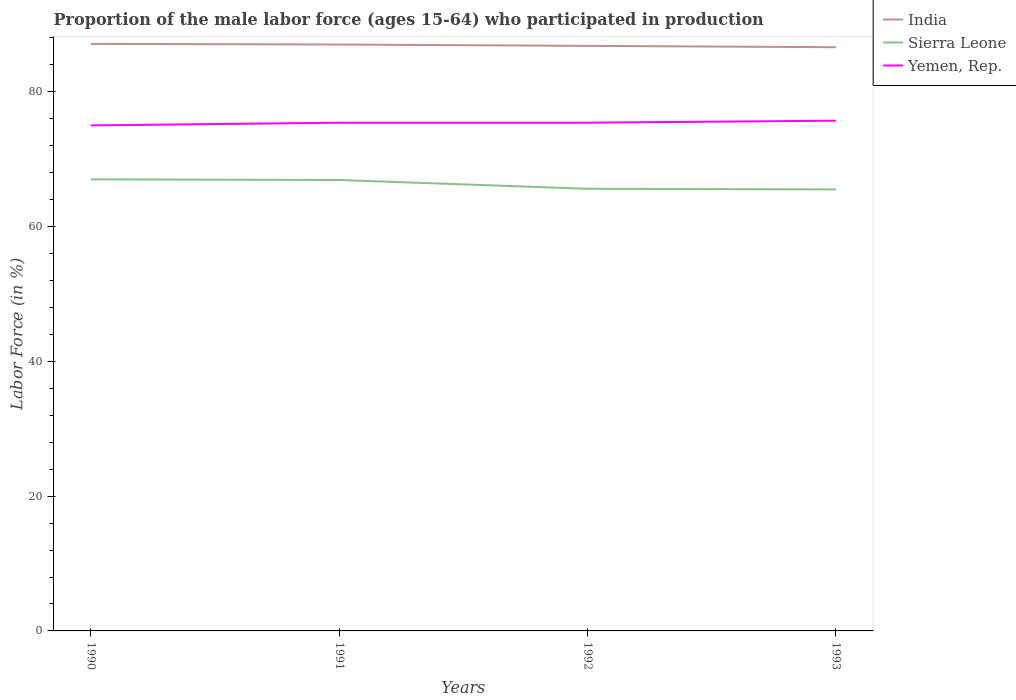How many different coloured lines are there?
Provide a short and direct response. 3. Is the number of lines equal to the number of legend labels?
Offer a terse response. Yes. Across all years, what is the maximum proportion of the male labor force who participated in production in Sierra Leone?
Offer a very short reply. 65.5. What is the total proportion of the male labor force who participated in production in Yemen, Rep. in the graph?
Make the answer very short. -0.7. How many years are there in the graph?
Give a very brief answer. 4. What is the difference between two consecutive major ticks on the Y-axis?
Ensure brevity in your answer.  20. How many legend labels are there?
Give a very brief answer. 3. How are the legend labels stacked?
Keep it short and to the point. Vertical. What is the title of the graph?
Your answer should be very brief. Proportion of the male labor force (ages 15-64) who participated in production. What is the label or title of the X-axis?
Provide a succinct answer. Years. What is the Labor Force (in %) in India in 1990?
Keep it short and to the point. 87.1. What is the Labor Force (in %) in Sierra Leone in 1991?
Provide a short and direct response. 66.9. What is the Labor Force (in %) in Yemen, Rep. in 1991?
Your answer should be compact. 75.4. What is the Labor Force (in %) of India in 1992?
Provide a short and direct response. 86.8. What is the Labor Force (in %) in Sierra Leone in 1992?
Your answer should be compact. 65.6. What is the Labor Force (in %) of Yemen, Rep. in 1992?
Your response must be concise. 75.4. What is the Labor Force (in %) in India in 1993?
Provide a succinct answer. 86.6. What is the Labor Force (in %) in Sierra Leone in 1993?
Make the answer very short. 65.5. What is the Labor Force (in %) of Yemen, Rep. in 1993?
Your response must be concise. 75.7. Across all years, what is the maximum Labor Force (in %) of India?
Your answer should be compact. 87.1. Across all years, what is the maximum Labor Force (in %) of Yemen, Rep.?
Give a very brief answer. 75.7. Across all years, what is the minimum Labor Force (in %) in India?
Offer a terse response. 86.6. Across all years, what is the minimum Labor Force (in %) of Sierra Leone?
Give a very brief answer. 65.5. What is the total Labor Force (in %) in India in the graph?
Your answer should be very brief. 347.5. What is the total Labor Force (in %) of Sierra Leone in the graph?
Offer a terse response. 265. What is the total Labor Force (in %) in Yemen, Rep. in the graph?
Give a very brief answer. 301.5. What is the difference between the Labor Force (in %) of India in 1990 and that in 1991?
Give a very brief answer. 0.1. What is the difference between the Labor Force (in %) of Sierra Leone in 1990 and that in 1991?
Your answer should be compact. 0.1. What is the difference between the Labor Force (in %) in India in 1990 and that in 1992?
Make the answer very short. 0.3. What is the difference between the Labor Force (in %) in Sierra Leone in 1990 and that in 1992?
Ensure brevity in your answer.  1.4. What is the difference between the Labor Force (in %) in Yemen, Rep. in 1990 and that in 1993?
Your answer should be compact. -0.7. What is the difference between the Labor Force (in %) of India in 1991 and that in 1993?
Give a very brief answer. 0.4. What is the difference between the Labor Force (in %) of Sierra Leone in 1991 and that in 1993?
Make the answer very short. 1.4. What is the difference between the Labor Force (in %) of Yemen, Rep. in 1991 and that in 1993?
Ensure brevity in your answer.  -0.3. What is the difference between the Labor Force (in %) of Sierra Leone in 1992 and that in 1993?
Make the answer very short. 0.1. What is the difference between the Labor Force (in %) in Yemen, Rep. in 1992 and that in 1993?
Make the answer very short. -0.3. What is the difference between the Labor Force (in %) of India in 1990 and the Labor Force (in %) of Sierra Leone in 1991?
Ensure brevity in your answer.  20.2. What is the difference between the Labor Force (in %) of India in 1990 and the Labor Force (in %) of Yemen, Rep. in 1991?
Your answer should be compact. 11.7. What is the difference between the Labor Force (in %) in Sierra Leone in 1990 and the Labor Force (in %) in Yemen, Rep. in 1991?
Provide a succinct answer. -8.4. What is the difference between the Labor Force (in %) of Sierra Leone in 1990 and the Labor Force (in %) of Yemen, Rep. in 1992?
Keep it short and to the point. -8.4. What is the difference between the Labor Force (in %) in India in 1990 and the Labor Force (in %) in Sierra Leone in 1993?
Your answer should be compact. 21.6. What is the difference between the Labor Force (in %) in India in 1990 and the Labor Force (in %) in Yemen, Rep. in 1993?
Your response must be concise. 11.4. What is the difference between the Labor Force (in %) in Sierra Leone in 1990 and the Labor Force (in %) in Yemen, Rep. in 1993?
Provide a succinct answer. -8.7. What is the difference between the Labor Force (in %) of India in 1991 and the Labor Force (in %) of Sierra Leone in 1992?
Make the answer very short. 21.4. What is the difference between the Labor Force (in %) in India in 1991 and the Labor Force (in %) in Yemen, Rep. in 1992?
Your answer should be very brief. 11.6. What is the difference between the Labor Force (in %) of Sierra Leone in 1991 and the Labor Force (in %) of Yemen, Rep. in 1992?
Ensure brevity in your answer.  -8.5. What is the difference between the Labor Force (in %) of India in 1991 and the Labor Force (in %) of Sierra Leone in 1993?
Your answer should be very brief. 21.5. What is the difference between the Labor Force (in %) of India in 1992 and the Labor Force (in %) of Sierra Leone in 1993?
Provide a short and direct response. 21.3. What is the average Labor Force (in %) of India per year?
Ensure brevity in your answer.  86.88. What is the average Labor Force (in %) of Sierra Leone per year?
Make the answer very short. 66.25. What is the average Labor Force (in %) in Yemen, Rep. per year?
Ensure brevity in your answer.  75.38. In the year 1990, what is the difference between the Labor Force (in %) of India and Labor Force (in %) of Sierra Leone?
Offer a terse response. 20.1. In the year 1990, what is the difference between the Labor Force (in %) in Sierra Leone and Labor Force (in %) in Yemen, Rep.?
Keep it short and to the point. -8. In the year 1991, what is the difference between the Labor Force (in %) of India and Labor Force (in %) of Sierra Leone?
Provide a short and direct response. 20.1. In the year 1991, what is the difference between the Labor Force (in %) of Sierra Leone and Labor Force (in %) of Yemen, Rep.?
Offer a very short reply. -8.5. In the year 1992, what is the difference between the Labor Force (in %) of India and Labor Force (in %) of Sierra Leone?
Your answer should be very brief. 21.2. In the year 1992, what is the difference between the Labor Force (in %) of Sierra Leone and Labor Force (in %) of Yemen, Rep.?
Provide a succinct answer. -9.8. In the year 1993, what is the difference between the Labor Force (in %) of India and Labor Force (in %) of Sierra Leone?
Your response must be concise. 21.1. In the year 1993, what is the difference between the Labor Force (in %) in India and Labor Force (in %) in Yemen, Rep.?
Provide a short and direct response. 10.9. In the year 1993, what is the difference between the Labor Force (in %) in Sierra Leone and Labor Force (in %) in Yemen, Rep.?
Offer a very short reply. -10.2. What is the ratio of the Labor Force (in %) in India in 1990 to that in 1991?
Offer a terse response. 1. What is the ratio of the Labor Force (in %) in Sierra Leone in 1990 to that in 1991?
Make the answer very short. 1. What is the ratio of the Labor Force (in %) in India in 1990 to that in 1992?
Ensure brevity in your answer.  1. What is the ratio of the Labor Force (in %) of Sierra Leone in 1990 to that in 1992?
Your response must be concise. 1.02. What is the ratio of the Labor Force (in %) of India in 1990 to that in 1993?
Offer a very short reply. 1.01. What is the ratio of the Labor Force (in %) in Sierra Leone in 1990 to that in 1993?
Make the answer very short. 1.02. What is the ratio of the Labor Force (in %) of Sierra Leone in 1991 to that in 1992?
Give a very brief answer. 1.02. What is the ratio of the Labor Force (in %) of Yemen, Rep. in 1991 to that in 1992?
Your answer should be compact. 1. What is the ratio of the Labor Force (in %) in India in 1991 to that in 1993?
Offer a terse response. 1. What is the ratio of the Labor Force (in %) of Sierra Leone in 1991 to that in 1993?
Your response must be concise. 1.02. What is the ratio of the Labor Force (in %) in Yemen, Rep. in 1991 to that in 1993?
Your answer should be compact. 1. What is the ratio of the Labor Force (in %) in Sierra Leone in 1992 to that in 1993?
Provide a short and direct response. 1. What is the ratio of the Labor Force (in %) of Yemen, Rep. in 1992 to that in 1993?
Your response must be concise. 1. What is the difference between the highest and the second highest Labor Force (in %) of Sierra Leone?
Provide a short and direct response. 0.1. What is the difference between the highest and the second highest Labor Force (in %) in Yemen, Rep.?
Ensure brevity in your answer.  0.3. What is the difference between the highest and the lowest Labor Force (in %) of India?
Make the answer very short. 0.5. What is the difference between the highest and the lowest Labor Force (in %) in Yemen, Rep.?
Keep it short and to the point. 0.7. 